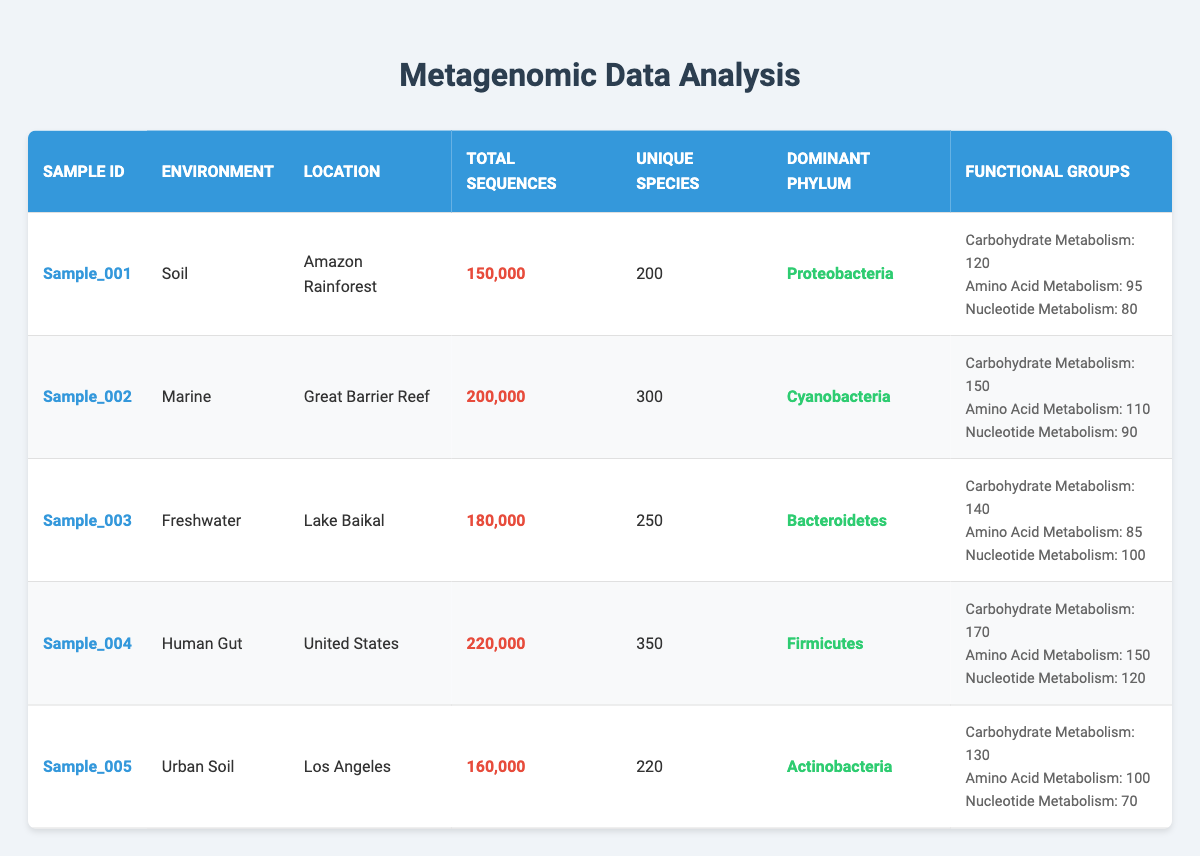What is the dominant phylum in Sample_003? According to the table, the dominant phylum for Sample_003 (Lake Baikal) is listed under the 'Dominant Phylum' column. It states "Bacteroidetes."
Answer: Bacteroidetes How many total sequences are there in Sample_004? The table indicates that Sample_004 (Human Gut) has a total of 220,000 sequences as stated in the 'Total Sequences' column.
Answer: 220,000 What is the sum of unique species across all samples? To find the sum of unique species, we need to add the values from the 'Unique Species' column: 200 (Sample_001) + 300 (Sample_002) + 250 (Sample_003) + 350 (Sample_004) + 220 (Sample_005) = 1320.
Answer: 1320 Is the total number of sequences in Sample_002 greater than that in Sample_005? By comparing the 'Total Sequences' values, Sample_002 has 200,000 sequences, while Sample_005 has 160,000 sequences. Since 200,000 is greater than 160,000, the statement is true.
Answer: Yes Which sample has the highest number of carbohydrate metabolism functional group entries? Sample_004 (Human Gut) has 170 entries for carbohydrate metabolism, which is the highest compared to other samples. Sample_001 has 120, Sample_002 has 150, Sample_003 has 140, and Sample_005 has 130.
Answer: Sample_004 What is the average number of unique species across the samples? To calculate the average, we take the total unique species (200 + 300 + 250 + 350 + 220 = 1320) and divide by the number of samples (5). So, 1320/5 = 264.
Answer: 264 Does Sample_001 have more unique species than Sample_005? Checking the values in the table, Sample_001 has 200 unique species and Sample_005 has 220 unique species. Since 200 is not greater than 220, the statement is false.
Answer: No Which environment has the greatest total sequences? By comparing the 'Total Sequences' column, we find that Sample_004 (Human Gut) has the highest count at 220,000 sequences, which is greater than the counts from all other environments.
Answer: Human Gut 